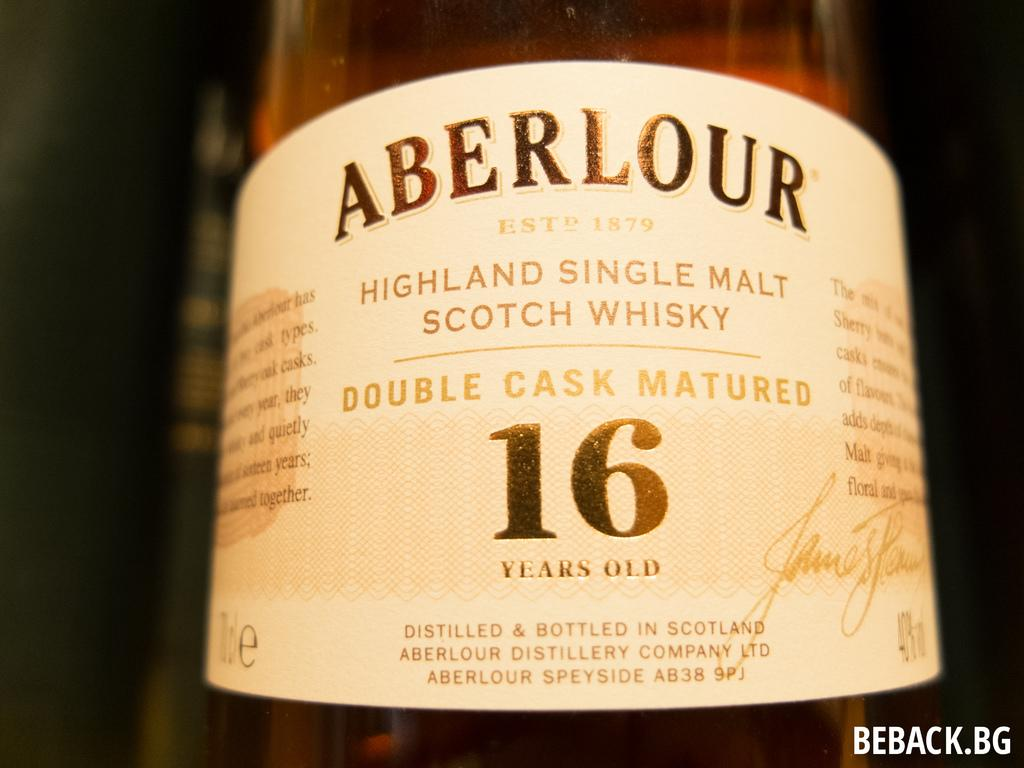What object can be seen in the image? There is a glass bottle in the image. What is written on the bottle? The word "abarlore" is written on the bottle. How does the earthquake affect the ink inside the bottle? There is no earthquake or ink present in the image; it only features a glass bottle with the word "abarlore" written on it. 